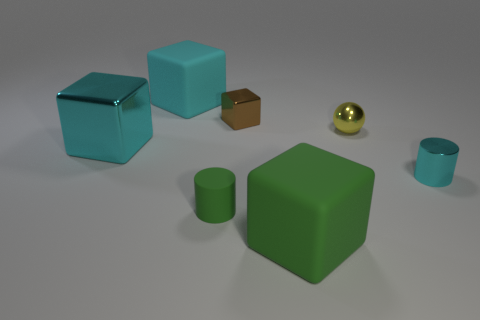Is the material of the big green object the same as the small green object?
Offer a terse response. Yes. There is a matte block behind the cyan shiny object right of the big rubber object that is in front of the small cyan cylinder; how big is it?
Provide a short and direct response. Large. What shape is the shiny thing that is the same size as the cyan rubber block?
Provide a succinct answer. Cube. Is there a green cube behind the green matte thing that is on the left side of the tiny metal object that is on the left side of the tiny yellow shiny ball?
Make the answer very short. No. There is a green cylinder that is the same size as the brown metallic cube; what is its material?
Ensure brevity in your answer.  Rubber. Does the cyan rubber object have the same size as the cylinder that is right of the tiny metallic sphere?
Your response must be concise. No. How many large cyan shiny things have the same shape as the brown shiny object?
Make the answer very short. 1. There is a large block that is the same color as the matte cylinder; what is its material?
Your response must be concise. Rubber. Is the size of the cyan metallic object that is behind the cyan metallic cylinder the same as the matte block behind the shiny ball?
Ensure brevity in your answer.  Yes. There is a large thing that is behind the small yellow thing; what is its shape?
Give a very brief answer. Cube. 